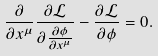<formula> <loc_0><loc_0><loc_500><loc_500>\frac { \partial } { \partial x ^ { \mu } } \frac { \partial { \mathcal { L } } } { \partial \frac { \partial \phi } { \partial x ^ { \mu } } } - \frac { \partial { \mathcal { L } } } { \partial \phi } = 0 .</formula> 